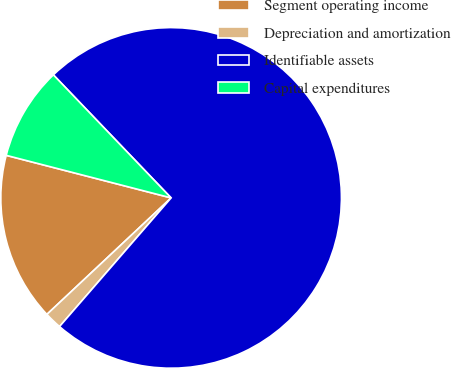Convert chart. <chart><loc_0><loc_0><loc_500><loc_500><pie_chart><fcel>Segment operating income<fcel>Depreciation and amortization<fcel>Identifiable assets<fcel>Capital expenditures<nl><fcel>16.01%<fcel>1.64%<fcel>73.52%<fcel>8.83%<nl></chart> 